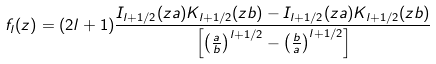<formula> <loc_0><loc_0><loc_500><loc_500>f _ { l } ( z ) = ( 2 l + 1 ) \frac { I _ { l + 1 / 2 } ( z a ) K _ { l + 1 / 2 } ( z b ) - I _ { l + 1 / 2 } ( z a ) K _ { l + 1 / 2 } ( z b ) } { \left [ \left ( \frac { a } { b } \right ) ^ { l + 1 / 2 } - \left ( \frac { b } { a } \right ) ^ { l + 1 / 2 } \right ] }</formula> 